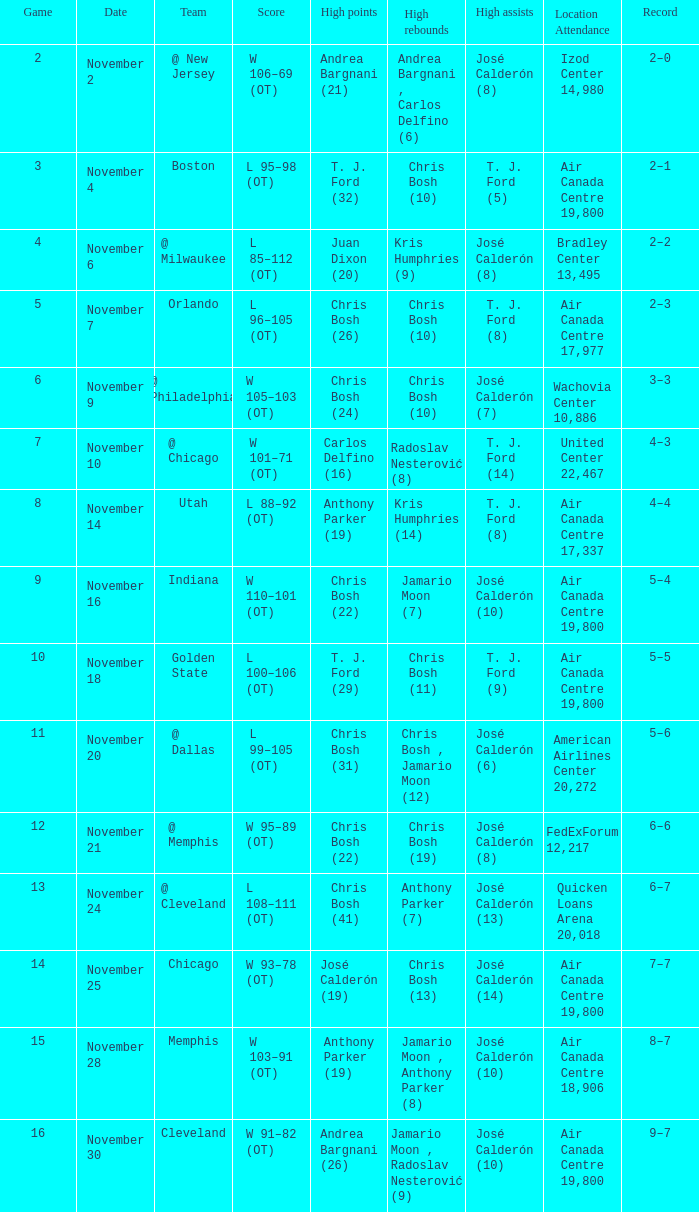What is the score when the team is at cleveland? L 108–111 (OT). 